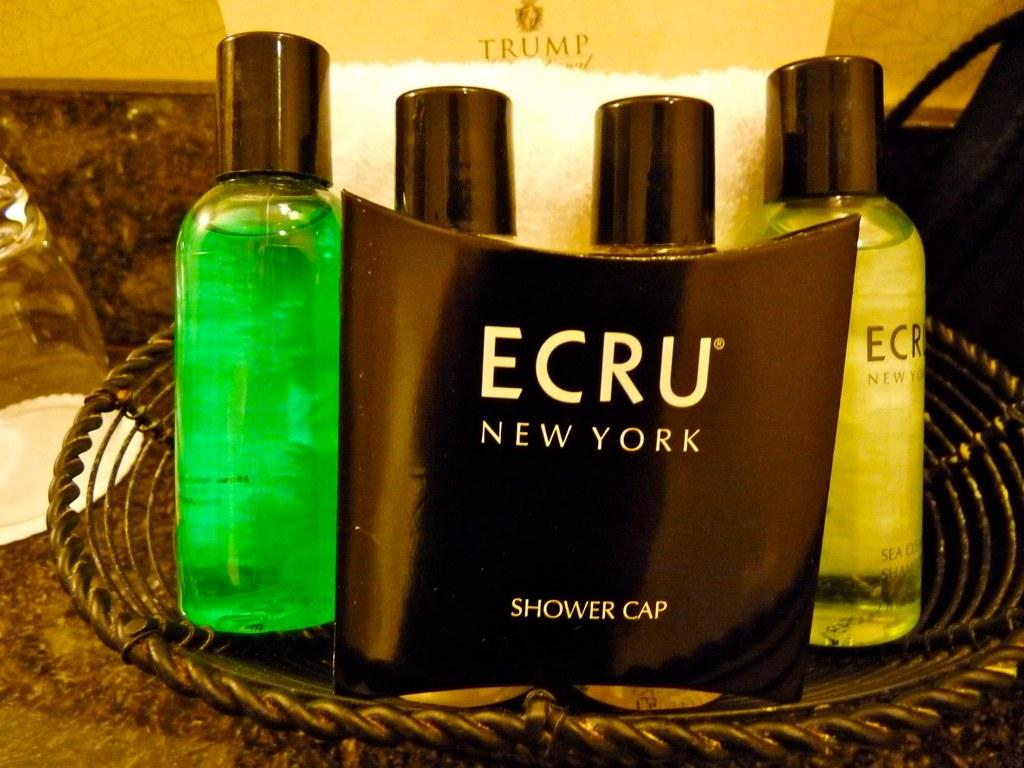<image>
Write a terse but informative summary of the picture. Hotel complimentary mini bottles in a  small bathroom basket are supplied by ECRU of New York. 